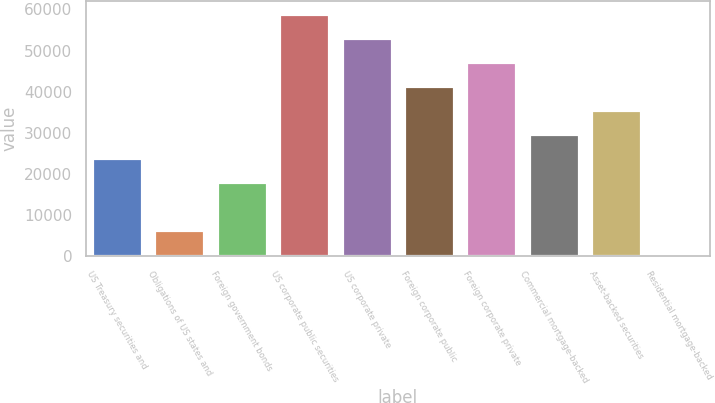<chart> <loc_0><loc_0><loc_500><loc_500><bar_chart><fcel>US Treasury securities and<fcel>Obligations of US states and<fcel>Foreign government bonds<fcel>US corporate public securities<fcel>US corporate private<fcel>Foreign corporate public<fcel>Foreign corporate private<fcel>Commercial mortgage-backed<fcel>Asset-backed securities<fcel>Residential mortgage-backed<nl><fcel>23932.4<fcel>6401.6<fcel>18088.8<fcel>58994<fcel>53150.4<fcel>41463.2<fcel>47306.8<fcel>29776<fcel>35619.6<fcel>558<nl></chart> 